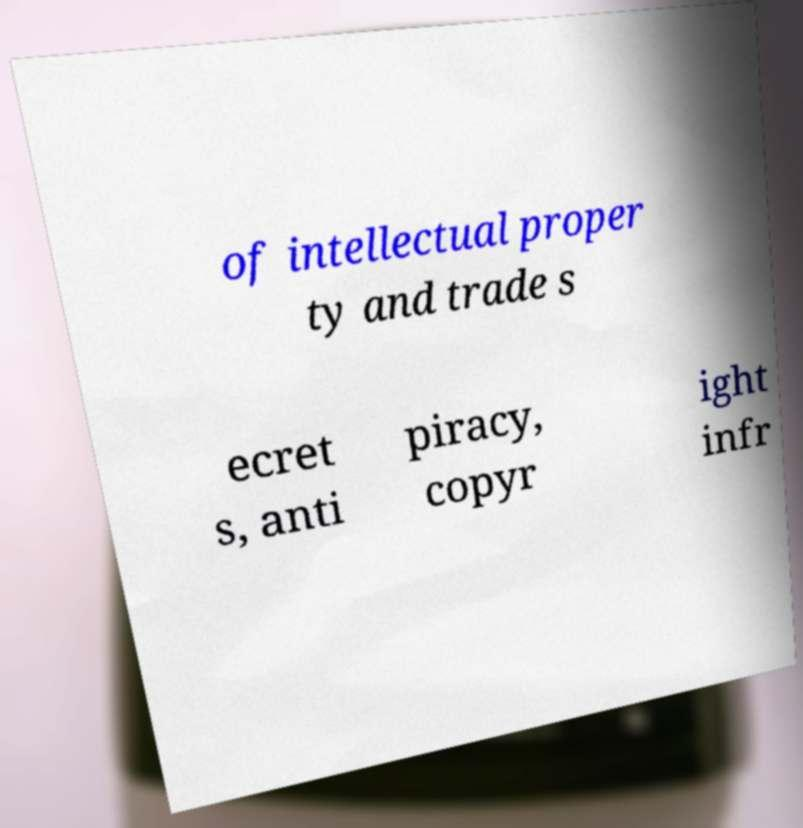What messages or text are displayed in this image? I need them in a readable, typed format. of intellectual proper ty and trade s ecret s, anti piracy, copyr ight infr 